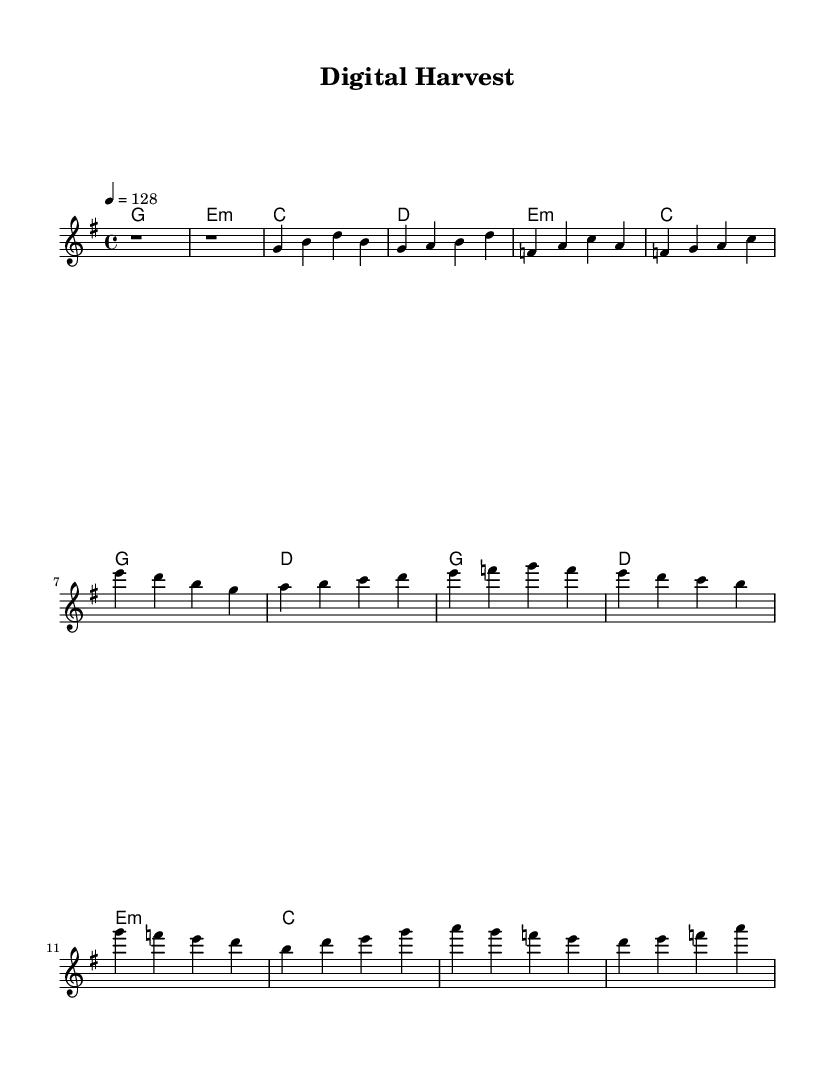What is the key signature of this music? The key signature is G major, which has one sharp (F#). This can be determined from the initial part of the score where the key signature is indicated.
Answer: G major What is the time signature of this piece? The time signature is 4/4. This is shown at the beginning of the score where the time signature is explicitly notated in the time signature section.
Answer: 4/4 What is the tempo marking in BPM? The tempo is marked at 128 beats per minute, which is noted in the tempo directive at the beginning.
Answer: 128 How many measures are in the verse section? The verse section consists of four measures, as seen from the melody and harmony sections where each line represents a measure.
Answer: 4 What type of chords are primarily used in the harmony section? The harmony section uses major and minor chords. In the chord mode, we can see both types represented (G major, E minor, C major, D major).
Answer: Major and minor What is the highest note in the melody? The highest note in the melody is G, which is reached at the beginning of the chorus section. We can identify this by looking at the pitch of the notes in the melody line.
Answer: G What is the structure of the piece? The structure of the piece is Intro, Verse, Pre-Chorus, and Chorus. This can be determined by the arrangement of sections within the score and the labels implied by their musical function.
Answer: Intro, Verse, Pre-Chorus, Chorus 